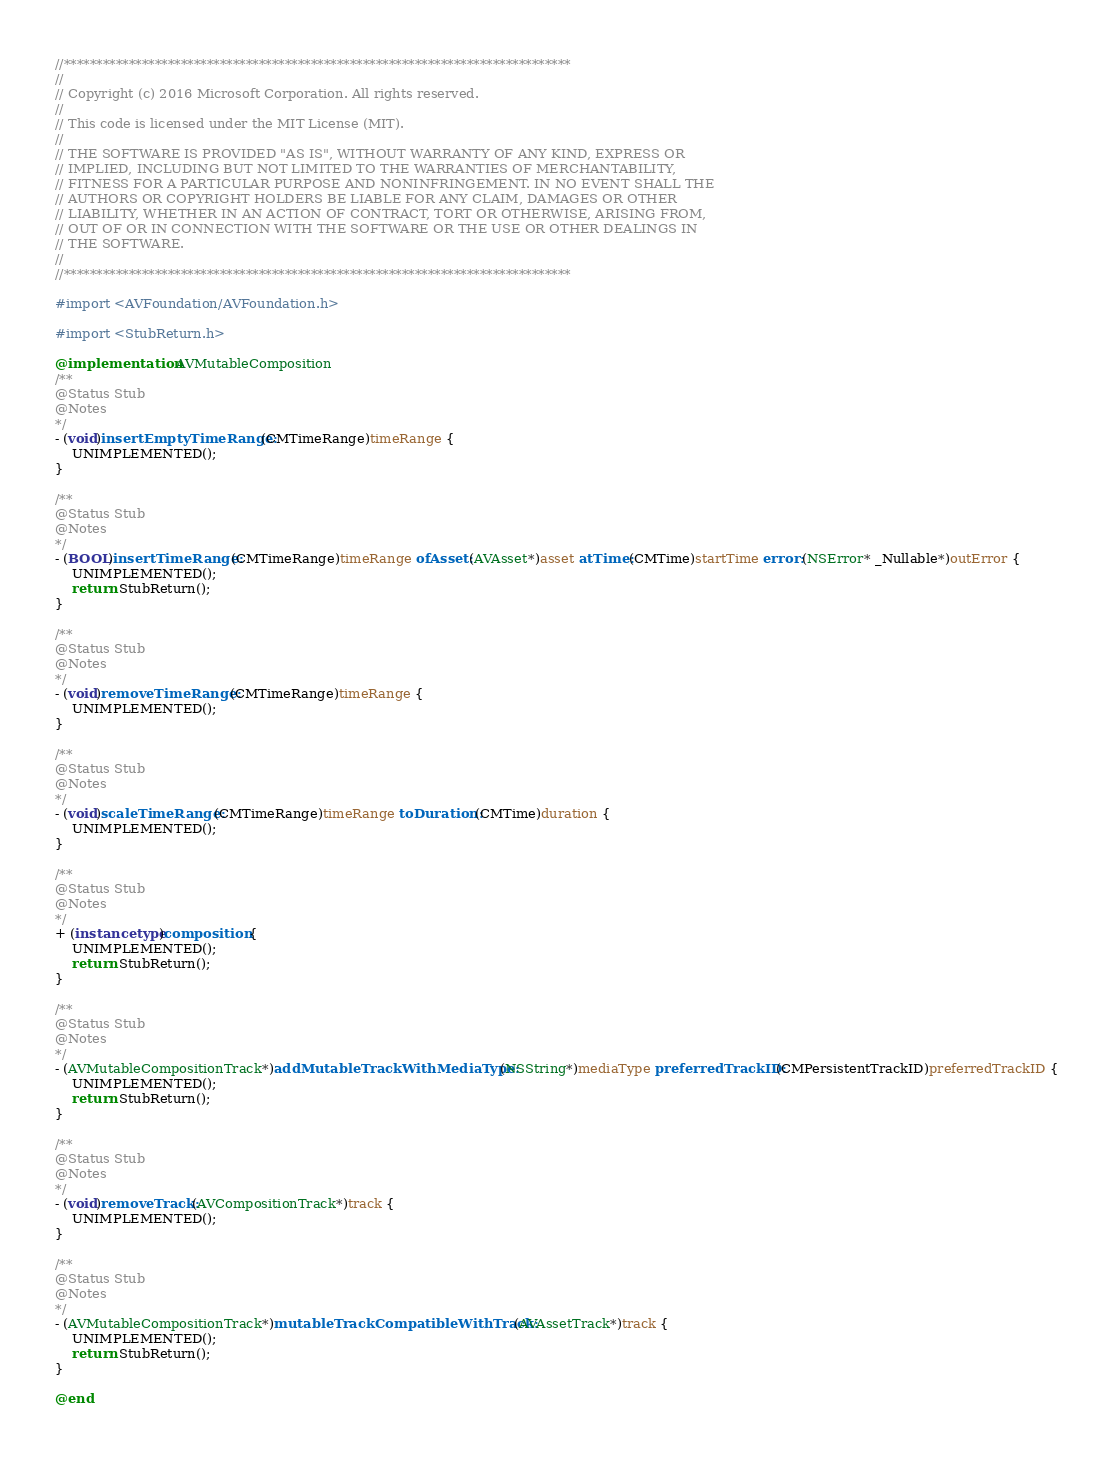Convert code to text. <code><loc_0><loc_0><loc_500><loc_500><_ObjectiveC_>//******************************************************************************
//
// Copyright (c) 2016 Microsoft Corporation. All rights reserved.
//
// This code is licensed under the MIT License (MIT).
//
// THE SOFTWARE IS PROVIDED "AS IS", WITHOUT WARRANTY OF ANY KIND, EXPRESS OR
// IMPLIED, INCLUDING BUT NOT LIMITED TO THE WARRANTIES OF MERCHANTABILITY,
// FITNESS FOR A PARTICULAR PURPOSE AND NONINFRINGEMENT. IN NO EVENT SHALL THE
// AUTHORS OR COPYRIGHT HOLDERS BE LIABLE FOR ANY CLAIM, DAMAGES OR OTHER
// LIABILITY, WHETHER IN AN ACTION OF CONTRACT, TORT OR OTHERWISE, ARISING FROM,
// OUT OF OR IN CONNECTION WITH THE SOFTWARE OR THE USE OR OTHER DEALINGS IN
// THE SOFTWARE.
//
//******************************************************************************

#import <AVFoundation/AVFoundation.h>

#import <StubReturn.h>

@implementation AVMutableComposition
/**
@Status Stub
@Notes
*/
- (void)insertEmptyTimeRange:(CMTimeRange)timeRange {
    UNIMPLEMENTED();
}

/**
@Status Stub
@Notes
*/
- (BOOL)insertTimeRange:(CMTimeRange)timeRange ofAsset:(AVAsset*)asset atTime:(CMTime)startTime error:(NSError* _Nullable*)outError {
    UNIMPLEMENTED();
    return StubReturn();
}

/**
@Status Stub
@Notes
*/
- (void)removeTimeRange:(CMTimeRange)timeRange {
    UNIMPLEMENTED();
}

/**
@Status Stub
@Notes
*/
- (void)scaleTimeRange:(CMTimeRange)timeRange toDuration:(CMTime)duration {
    UNIMPLEMENTED();
}

/**
@Status Stub
@Notes
*/
+ (instancetype)composition {
    UNIMPLEMENTED();
    return StubReturn();
}

/**
@Status Stub
@Notes
*/
- (AVMutableCompositionTrack*)addMutableTrackWithMediaType:(NSString*)mediaType preferredTrackID:(CMPersistentTrackID)preferredTrackID {
    UNIMPLEMENTED();
    return StubReturn();
}

/**
@Status Stub
@Notes
*/
- (void)removeTrack:(AVCompositionTrack*)track {
    UNIMPLEMENTED();
}

/**
@Status Stub
@Notes
*/
- (AVMutableCompositionTrack*)mutableTrackCompatibleWithTrack:(AVAssetTrack*)track {
    UNIMPLEMENTED();
    return StubReturn();
}

@end
</code> 